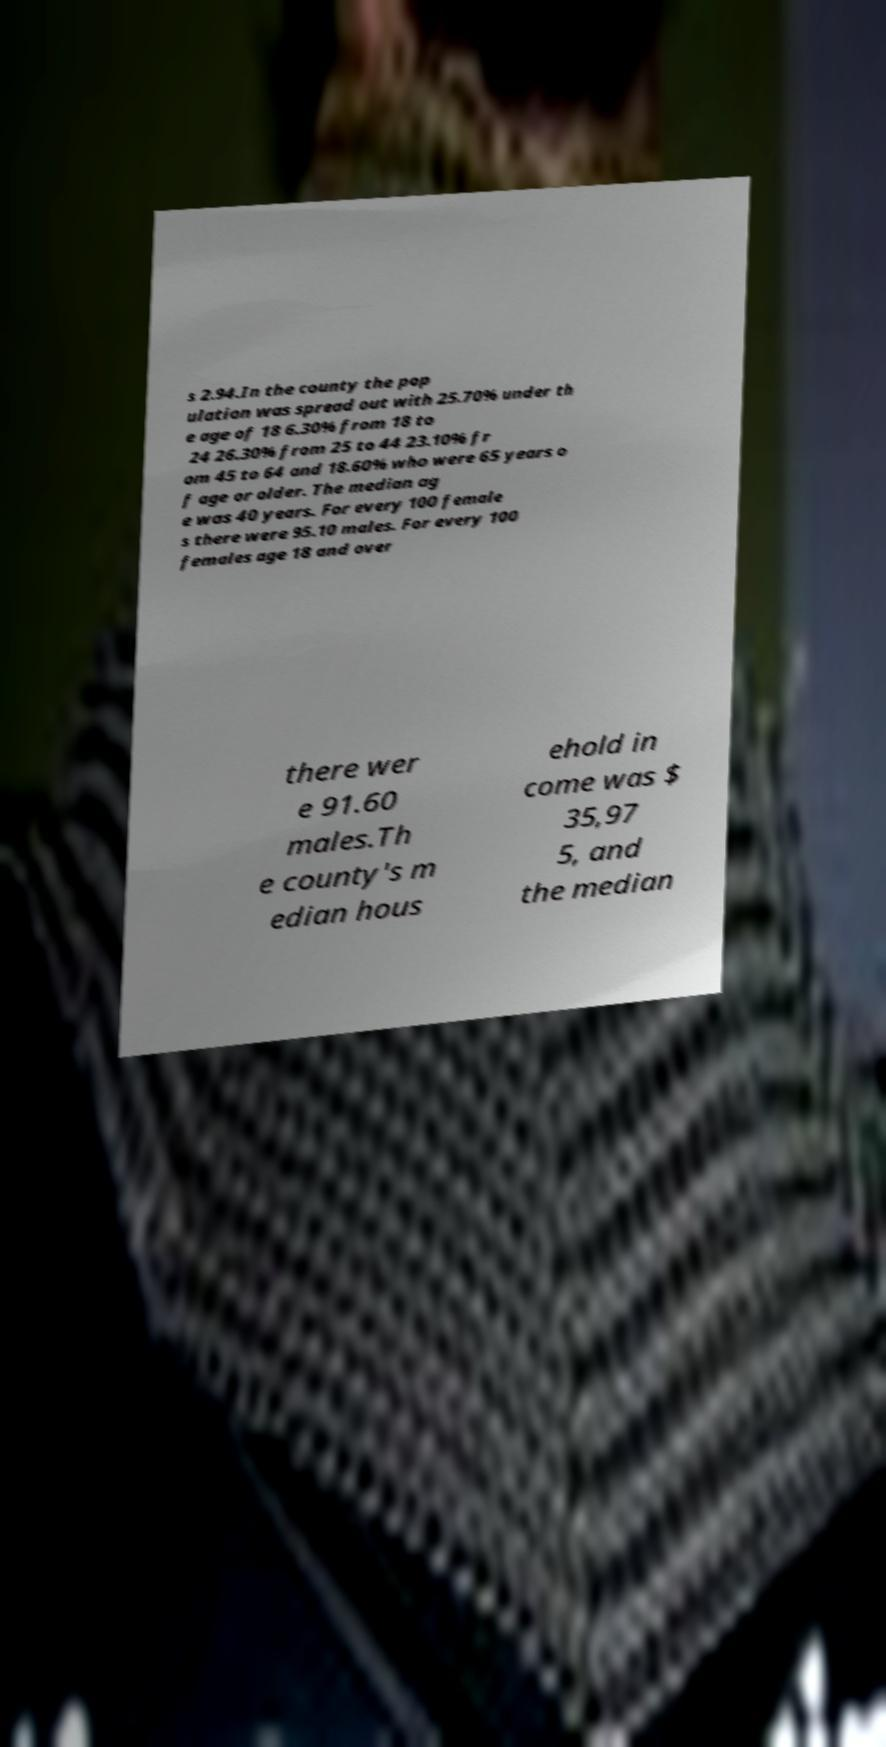Could you assist in decoding the text presented in this image and type it out clearly? s 2.94.In the county the pop ulation was spread out with 25.70% under th e age of 18 6.30% from 18 to 24 26.30% from 25 to 44 23.10% fr om 45 to 64 and 18.60% who were 65 years o f age or older. The median ag e was 40 years. For every 100 female s there were 95.10 males. For every 100 females age 18 and over there wer e 91.60 males.Th e county's m edian hous ehold in come was $ 35,97 5, and the median 